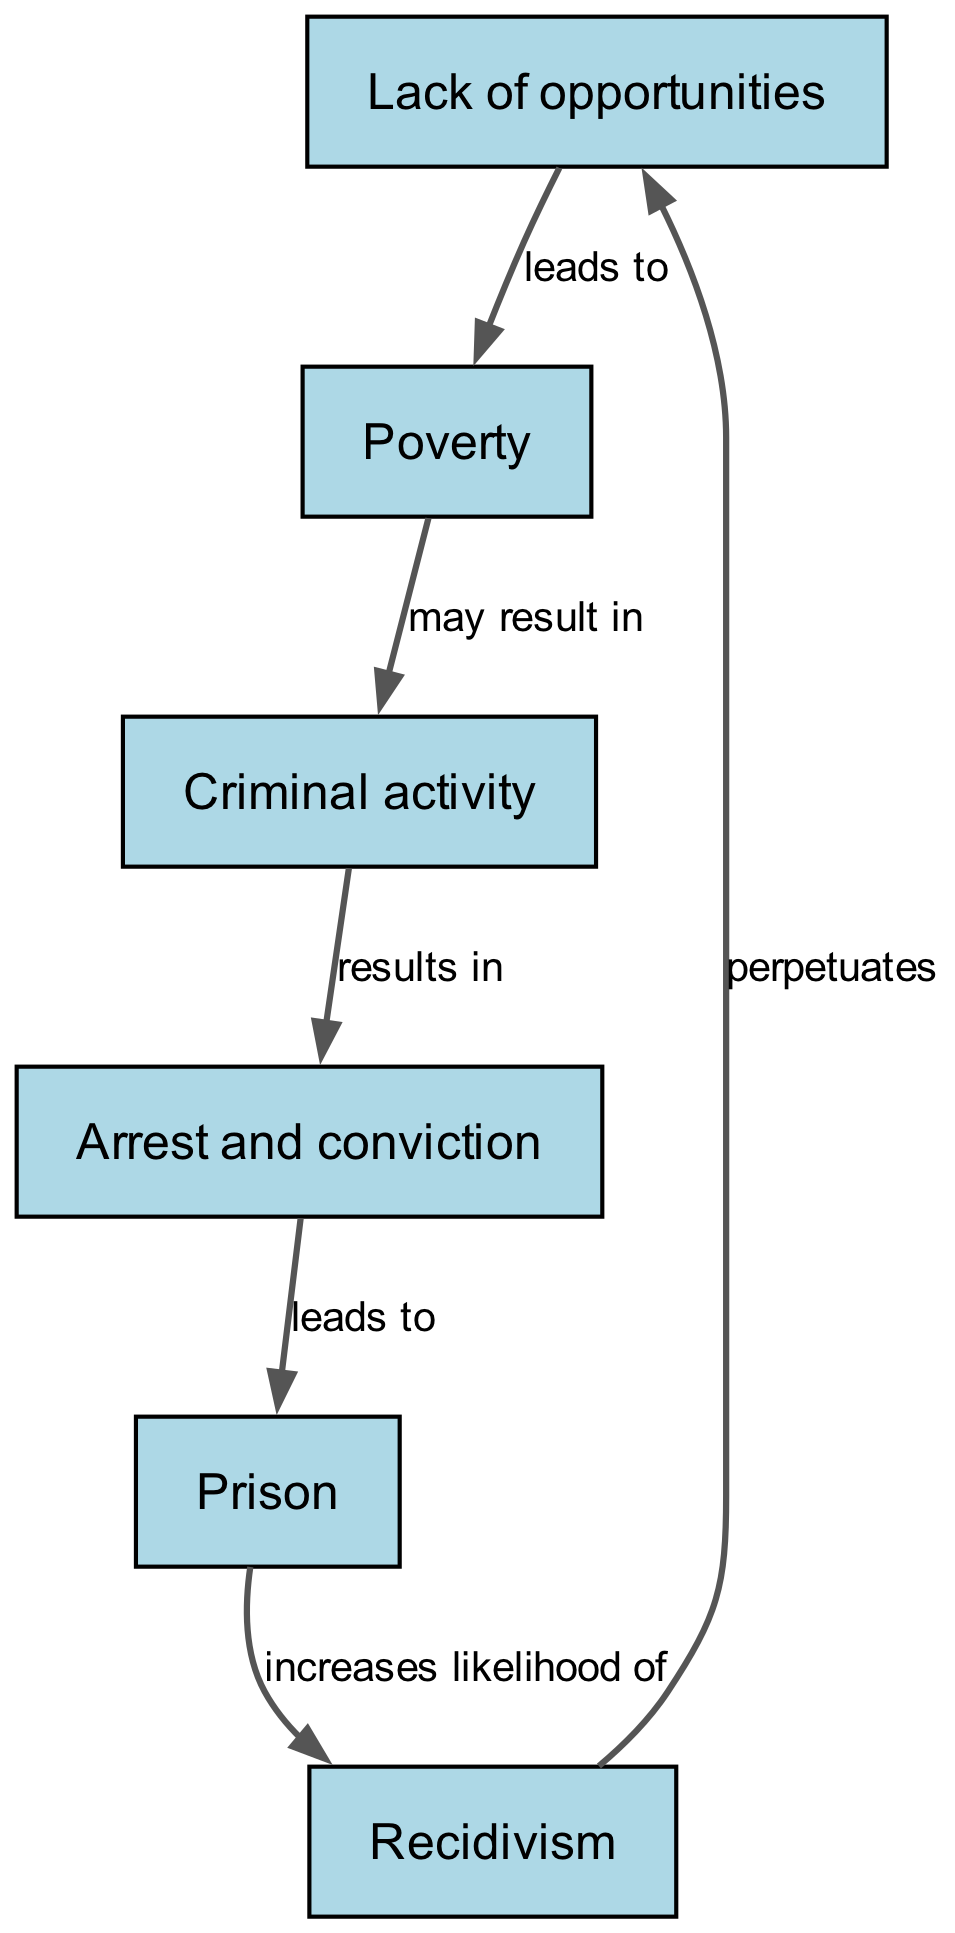What is the first node in the cycle? The diagram indicates that the first node is "Lack of opportunities" as it is the starting point of the food chain.
Answer: Lack of opportunities How many nodes are present in the food chain? The diagram lists six distinct nodes: "Lack of opportunities," "Poverty," "Criminal activity," "Arrest and conviction," "Prison," and "Recidivism." Thus, there are six nodes in total.
Answer: 6 What relationship exists between "Poverty" and "Criminal activity"? In the diagram, the relationship states that "Poverty may result in Criminal activity," indicating a potential cause-and-effect link between these two nodes.
Answer: may result in Which node leads to "Prison"? The diagram shows that the node "Arrest and conviction" leads to "Prison," demonstrating the progression from being arrested to serving time in prison.
Answer: Arrest and conviction What increases the likelihood of recidivism? According to the diagram, the node "Prison" increases the likelihood of "Recidivism," suggesting that serving time in prison makes it more likely for individuals to re-offend.
Answer: Prison What cycle completes the food chain? The diagram illustrates that "Recidivism perpetuates Lack of opportunities," which indicates that the cycle continues as recidivism brings individuals back to the starting condition of lacking opportunities.
Answer: perpetuates Which node directly precedes "Recidivism"? The diagram indicates that the node "Prison" directly precedes "Recidivism," showing that prison time is a factor leading to repeat offenses.
Answer: Prison What is the last node in the cycle? The last node in the diagram is "Recidivism," which reflects the final outcome in the cycle of poverty and crime before returning to the starting condition.
Answer: Recidivism How is the relationship from "Criminal activity" to "Arrest and conviction" defined? The relationship from "Criminal activity" to "Arrest and conviction" is defined as "results in," indicating that engaging in criminal activity directly leads to arrest and legal consequences.
Answer: results in 